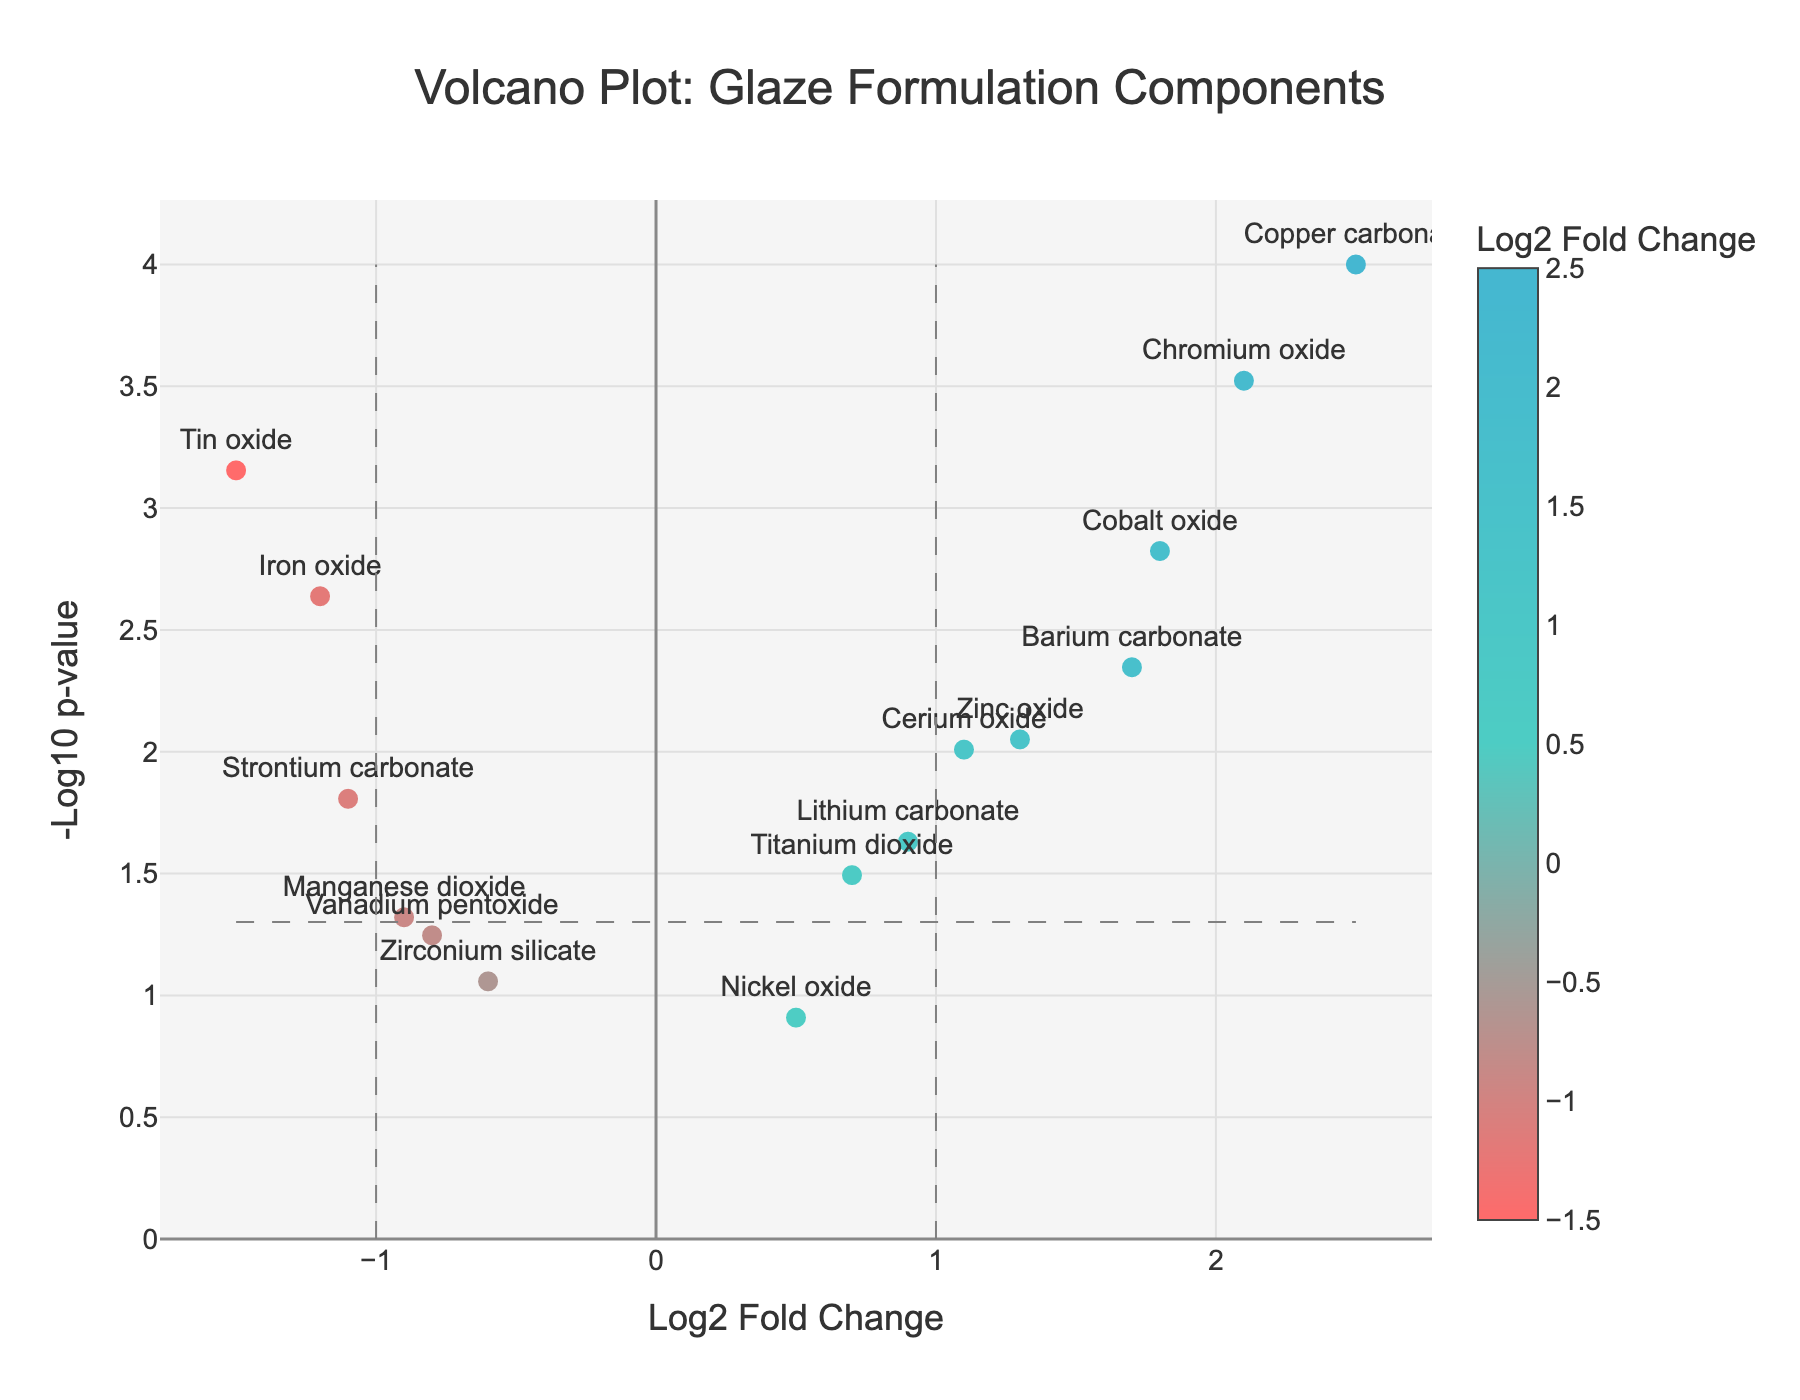What is the title of the plot? The title is typically displayed at the top of the plot. In this case, it reads 'Volcano Plot: Glaze Formulation Components'.
Answer: Volcano Plot: Glaze Formulation Components What does the x-axis represent? The x-axis is labeled 'Log2 Fold Change', indicating it represents the log2 fold change in the data points.
Answer: Log2 Fold Change What does the y-axis represent? The y-axis is labeled '-Log10 p-value', indicating it represents the negative log10 of the p-value.
Answer: -Log10 p-value Which component has the highest log2 fold change? By observing the x-axis, the component with the highest log2 fold change is Copper carbonate, with a log2 fold change of 2.5.
Answer: Copper carbonate Which component has the smallest p-value? The smallest p-value corresponds to the highest point on the y-axis. Here, Copper carbonate has the smallest p-value with the highest -Log10 p-value.
Answer: Copper carbonate How many components have a log2 fold change greater than 1? By inspecting the x-axis, components with log2 fold change greater than 1 are Copper carbonate, Cobalt oxide, Chromium oxide, Zinc oxide, Barium carbonate, and Cerium oxide. There are 6 components.
Answer: 6 Which component shows the most negative log2 fold change? By looking at the x-axis for negative values, Tin oxide shows the most negative log2 fold change at -1.5.
Answer: Tin oxide Are there any components that are not statistically significant? Components with a -Log10 p-value less than -log10(0.05) are considered not statistically significant. Vanadium pentoxide and Nickel oxide fall into this category.
Answer: Vanadium pentoxide and Nickel oxide Which component has the smallest -Log10 p-value but is still significant? By looking at points barely above the threshold -Log10(0.05), Manganese dioxide has the smallest -Log10 p-value but is still significant since it's slightly above the threshold line.
Answer: Manganese dioxide Compare the -Log10 p-values of Iron oxide and Strontium carbonate. Which one is higher? From the plot, compare the y-axis values of Iron oxide and Strontium carbonate. Iron oxide has a higher -Log10 p-value compared to Strontium carbonate.
Answer: Iron oxide 